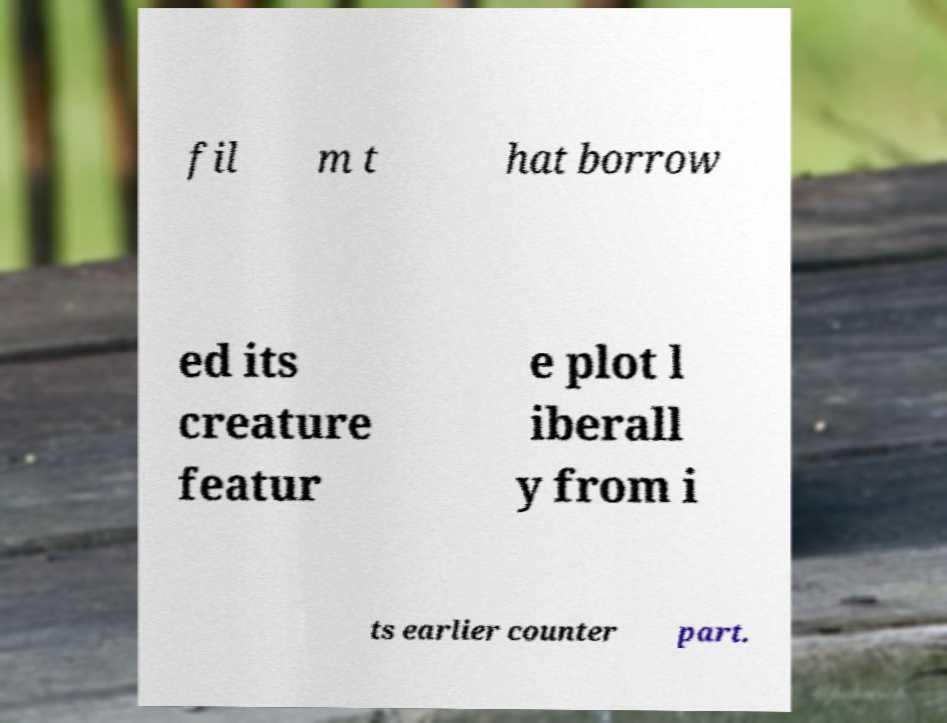Can you accurately transcribe the text from the provided image for me? fil m t hat borrow ed its creature featur e plot l iberall y from i ts earlier counter part. 